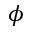<formula> <loc_0><loc_0><loc_500><loc_500>\phi</formula> 